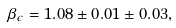<formula> <loc_0><loc_0><loc_500><loc_500>\beta _ { c } = 1 . 0 8 \pm 0 . 0 1 \pm 0 . 0 3 ,</formula> 